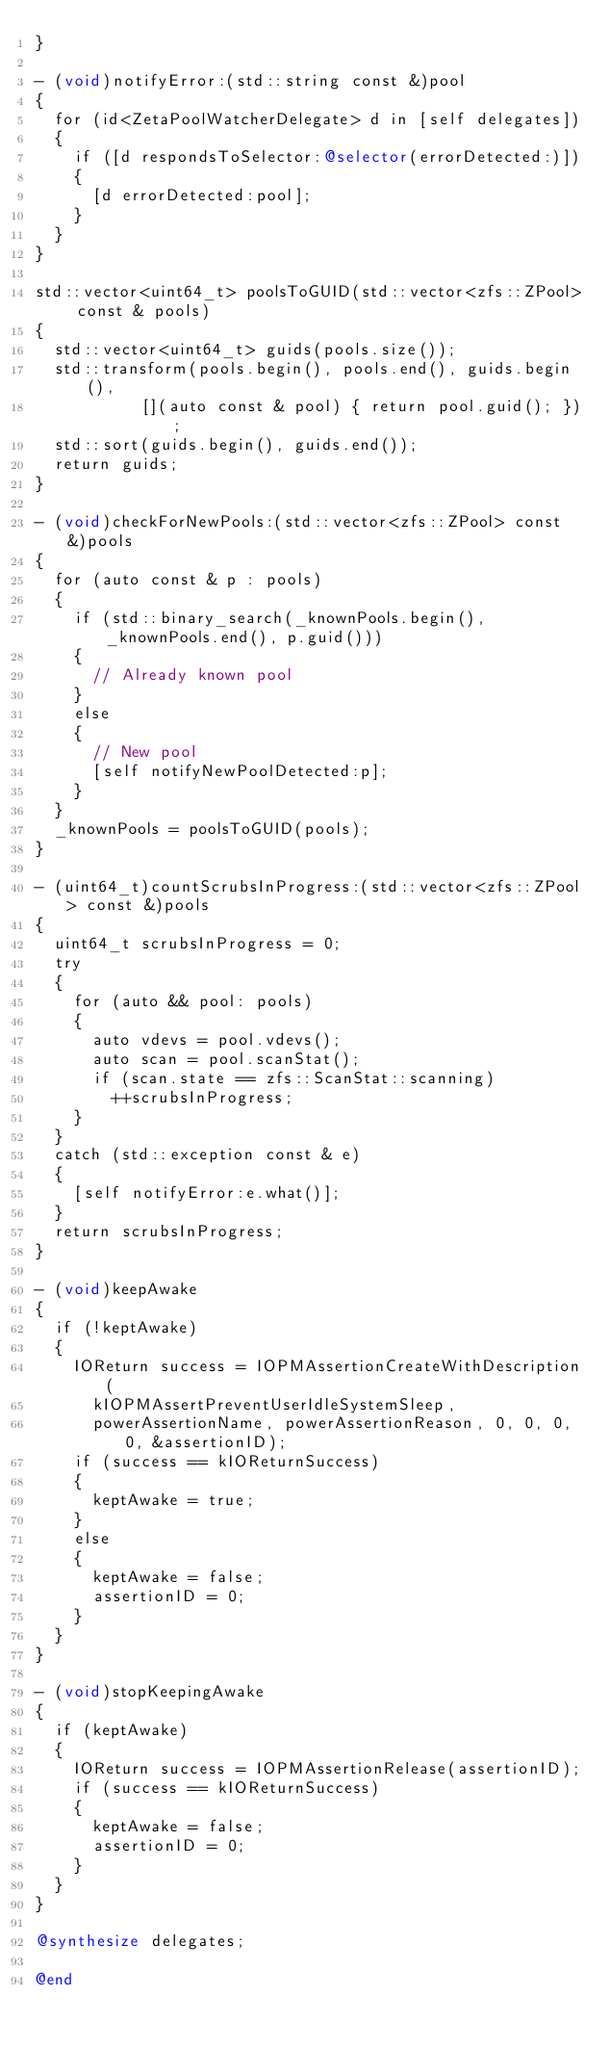<code> <loc_0><loc_0><loc_500><loc_500><_ObjectiveC_>}

- (void)notifyError:(std::string const &)pool
{
	for (id<ZetaPoolWatcherDelegate> d in [self delegates])
	{
		if ([d respondsToSelector:@selector(errorDetected:)])
		{
			[d errorDetected:pool];
		}
	}
}

std::vector<uint64_t> poolsToGUID(std::vector<zfs::ZPool> const & pools)
{
	std::vector<uint64_t> guids(pools.size());
	std::transform(pools.begin(), pools.end(), guids.begin(),
				   [](auto const & pool) { return pool.guid(); });
	std::sort(guids.begin(), guids.end());
	return guids;
}

- (void)checkForNewPools:(std::vector<zfs::ZPool> const &)pools
{
	for (auto const & p : pools)
	{
		if (std::binary_search(_knownPools.begin(), _knownPools.end(), p.guid()))
		{
			// Already known pool
		}
		else
		{
			// New pool
			[self notifyNewPoolDetected:p];
		}
	}
	_knownPools = poolsToGUID(pools);
}

- (uint64_t)countScrubsInProgress:(std::vector<zfs::ZPool> const &)pools
{
	uint64_t scrubsInProgress = 0;
	try
	{
		for (auto && pool: pools)
		{
			auto vdevs = pool.vdevs();
			auto scan = pool.scanStat();
			if (scan.state == zfs::ScanStat::scanning)
				++scrubsInProgress;
		}
	}
	catch (std::exception const & e)
	{
		[self notifyError:e.what()];
	}
	return scrubsInProgress;
}

- (void)keepAwake
{
	if (!keptAwake)
	{
		IOReturn success = IOPMAssertionCreateWithDescription(
			kIOPMAssertPreventUserIdleSystemSleep,
			powerAssertionName, powerAssertionReason, 0, 0, 0, 0, &assertionID);
		if (success == kIOReturnSuccess)
		{
			keptAwake = true;
		}
		else
		{
			keptAwake = false;
			assertionID = 0;
		}
	}
}

- (void)stopKeepingAwake
{
	if (keptAwake)
	{
		IOReturn success = IOPMAssertionRelease(assertionID);
		if (success == kIOReturnSuccess)
		{
			keptAwake = false;
			assertionID = 0;
		}
	}
}

@synthesize delegates;

@end
</code> 